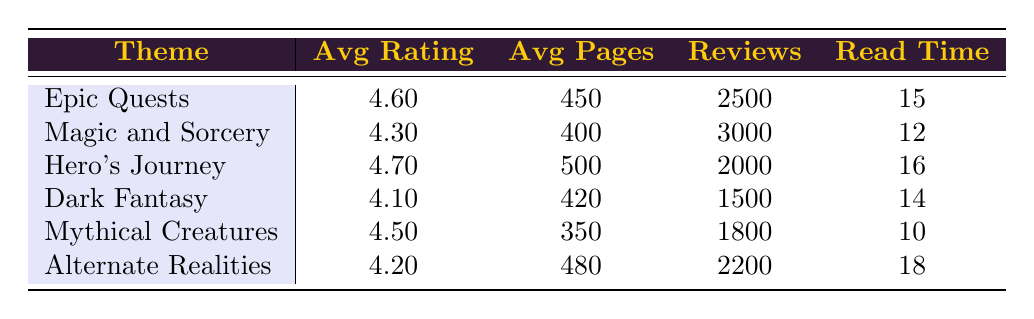What is the average reader rating for 'Magic and Sorcery'? Looking at the table, the average reader rating for 'Magic and Sorcery' is directly provided as 4.3.
Answer: 4.3 Which theme has the highest number of reviews? By comparing the 'number of reviews' column for all themes, 'Magic and Sorcery' has 3000 reviews, which is higher than any other theme listed.
Answer: Magic and Sorcery Is the average page count for 'Mythical Creatures' greater than 400 pages? The average page count for 'Mythical Creatures' is 350 pages, which is less than 400.
Answer: No What is the average time to read for the theme with the highest average reader rating? The theme with the highest average reader rating is 'Hero's Journey' with a rating of 4.7, and the average time to read is 16 hours.
Answer: 16 hours If we sum the average page counts of 'Epic Quests' and 'Hero's Journey', what do we get? The average page count for 'Epic Quests' is 450, and for 'Hero's Journey' it is 500. Adding these gives us 450 + 500 = 950.
Answer: 950 Which theme has a lower average rating: 'Dark Fantasy' or 'Alternate Realities'? 'Dark Fantasy' has an average rating of 4.1, while 'Alternate Realities' has an average rating of 4.2. So, 'Dark Fantasy' has the lower average rating.
Answer: Dark Fantasy How many themes have an average reader rating of 4.5 or higher? The themes with ratings of 4.5 or higher are 'Epic Quests' (4.6), 'Hero's Journey' (4.7), and 'Mythical Creatures' (4.5). Therefore, there are three themes that meet this criterion.
Answer: 3 What is the difference in average reader rating between 'Hero's Journey' and 'Dark Fantasy'? The average rating for 'Hero's Journey' is 4.7 and for 'Dark Fantasy' it is 4.1. The difference is calculated as 4.7 - 4.1 = 0.6.
Answer: 0.6 Is the average reader rating for 'Alternate Realities' higher or lower than the overall average of all themes? First, we must find the overall average rating for all themes. Adding the ratings gives us (4.6 + 4.3 + 4.7 + 4.1 + 4.5 + 4.2) = 26.4, and dividing by 6 gives an overall average of 4.4. 'Alternate Realities' has an average rating of 4.2, which is lower than the overall average.
Answer: Lower 